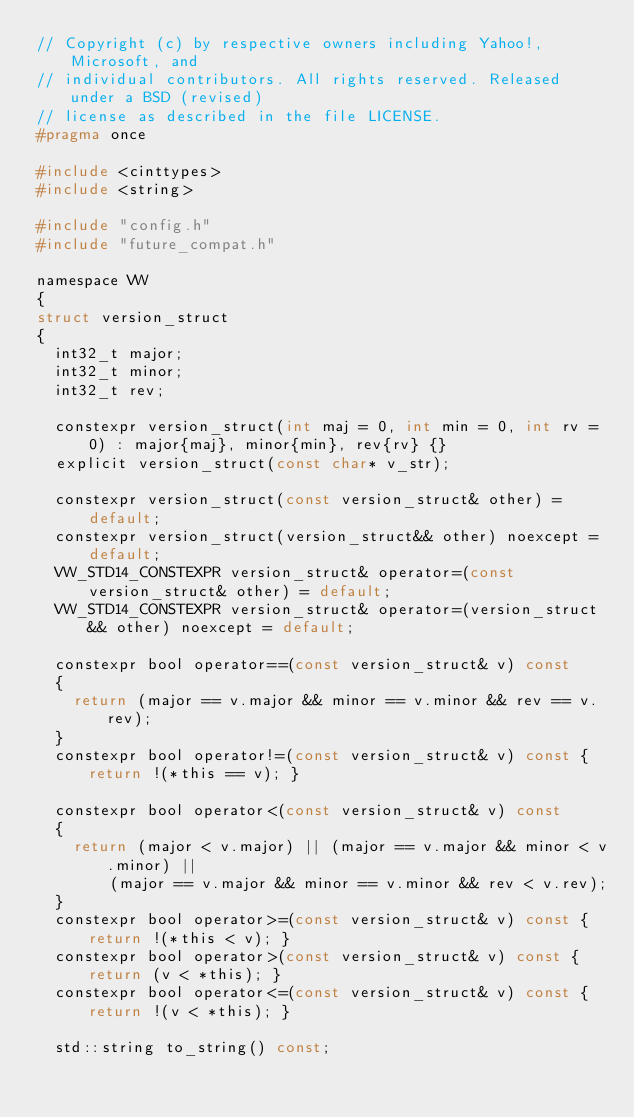Convert code to text. <code><loc_0><loc_0><loc_500><loc_500><_C_>// Copyright (c) by respective owners including Yahoo!, Microsoft, and
// individual contributors. All rights reserved. Released under a BSD (revised)
// license as described in the file LICENSE.
#pragma once

#include <cinttypes>
#include <string>

#include "config.h"
#include "future_compat.h"

namespace VW
{
struct version_struct
{
  int32_t major;
  int32_t minor;
  int32_t rev;

  constexpr version_struct(int maj = 0, int min = 0, int rv = 0) : major{maj}, minor{min}, rev{rv} {}
  explicit version_struct(const char* v_str);

  constexpr version_struct(const version_struct& other) = default;
  constexpr version_struct(version_struct&& other) noexcept = default;
  VW_STD14_CONSTEXPR version_struct& operator=(const version_struct& other) = default;
  VW_STD14_CONSTEXPR version_struct& operator=(version_struct&& other) noexcept = default;

  constexpr bool operator==(const version_struct& v) const
  {
    return (major == v.major && minor == v.minor && rev == v.rev);
  }
  constexpr bool operator!=(const version_struct& v) const { return !(*this == v); }

  constexpr bool operator<(const version_struct& v) const
  {
    return (major < v.major) || (major == v.major && minor < v.minor) ||
        (major == v.major && minor == v.minor && rev < v.rev);
  }
  constexpr bool operator>=(const version_struct& v) const { return !(*this < v); }
  constexpr bool operator>(const version_struct& v) const { return (v < *this); }
  constexpr bool operator<=(const version_struct& v) const { return !(v < *this); }

  std::string to_string() const;</code> 